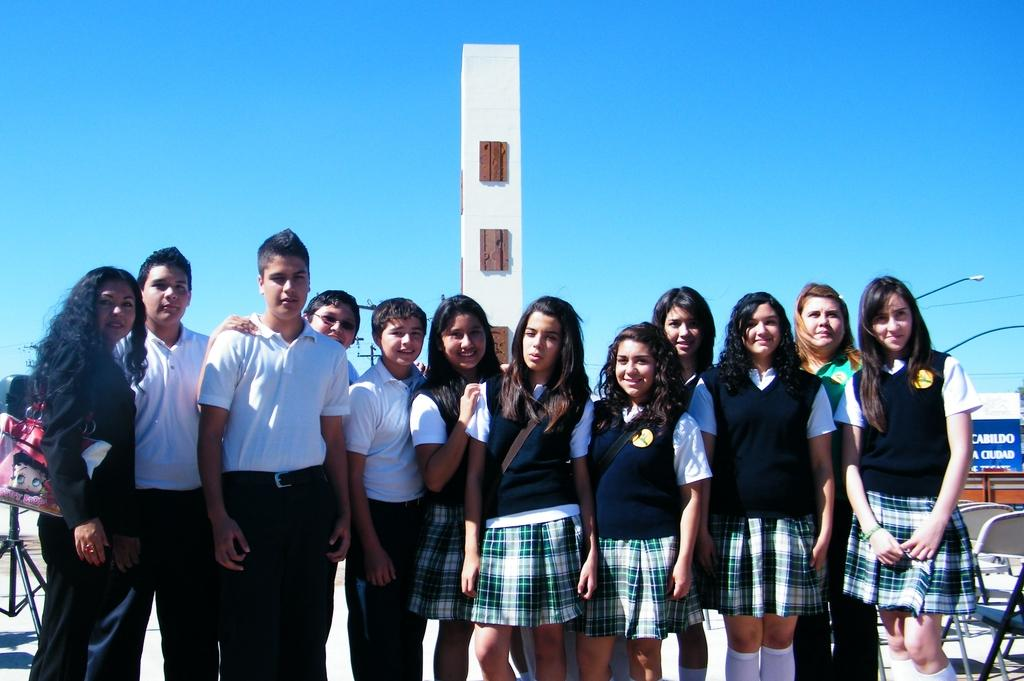How many people are in the image? There is a group of persons standing in the image. What can be seen in the background of the image? There are street lights, a pillar, a stand, and the sky visible in the background of the image. Are there any rabbits celebrating a birthday in the image? There are no rabbits or birthday celebrations present in the image. 